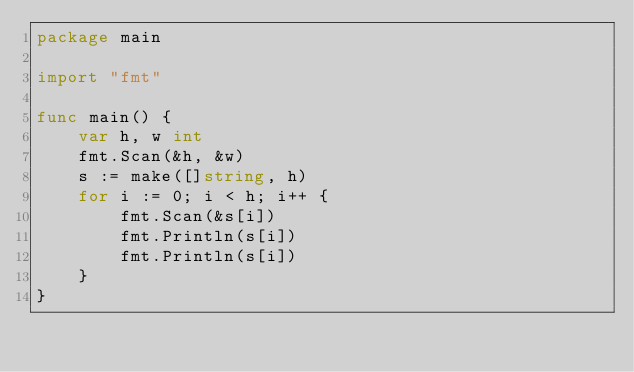Convert code to text. <code><loc_0><loc_0><loc_500><loc_500><_Go_>package main

import "fmt"

func main() {
	var h, w int
	fmt.Scan(&h, &w)
	s := make([]string, h)
	for i := 0; i < h; i++ {
		fmt.Scan(&s[i])
		fmt.Println(s[i])
		fmt.Println(s[i])
	}
}
</code> 